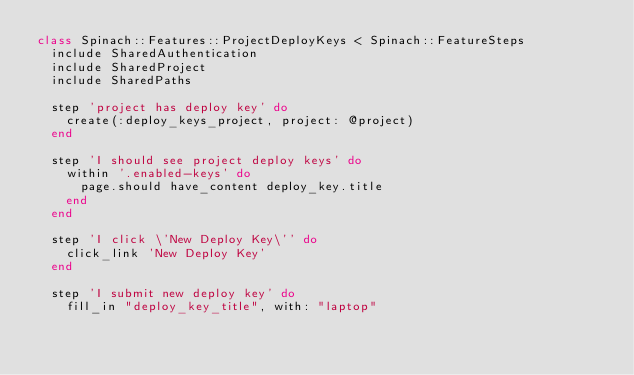<code> <loc_0><loc_0><loc_500><loc_500><_Ruby_>class Spinach::Features::ProjectDeployKeys < Spinach::FeatureSteps
  include SharedAuthentication
  include SharedProject
  include SharedPaths

  step 'project has deploy key' do
    create(:deploy_keys_project, project: @project)
  end

  step 'I should see project deploy keys' do
    within '.enabled-keys' do
      page.should have_content deploy_key.title
    end
  end

  step 'I click \'New Deploy Key\'' do
    click_link 'New Deploy Key'
  end

  step 'I submit new deploy key' do
    fill_in "deploy_key_title", with: "laptop"</code> 